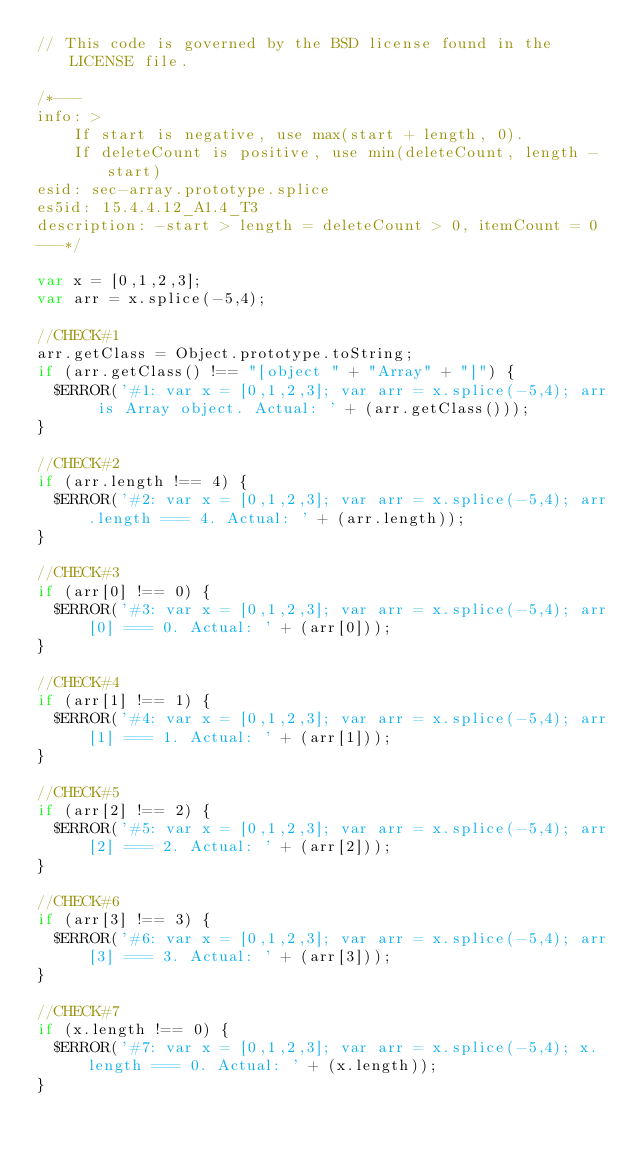Convert code to text. <code><loc_0><loc_0><loc_500><loc_500><_JavaScript_>// This code is governed by the BSD license found in the LICENSE file.

/*---
info: >
    If start is negative, use max(start + length, 0).
    If deleteCount is positive, use min(deleteCount, length - start)
esid: sec-array.prototype.splice
es5id: 15.4.4.12_A1.4_T3
description: -start > length = deleteCount > 0, itemCount = 0
---*/

var x = [0,1,2,3];
var arr = x.splice(-5,4);

//CHECK#1
arr.getClass = Object.prototype.toString;
if (arr.getClass() !== "[object " + "Array" + "]") {
  $ERROR('#1: var x = [0,1,2,3]; var arr = x.splice(-5,4); arr is Array object. Actual: ' + (arr.getClass()));
}

//CHECK#2
if (arr.length !== 4) {
  $ERROR('#2: var x = [0,1,2,3]; var arr = x.splice(-5,4); arr.length === 4. Actual: ' + (arr.length));
}

//CHECK#3
if (arr[0] !== 0) {
  $ERROR('#3: var x = [0,1,2,3]; var arr = x.splice(-5,4); arr[0] === 0. Actual: ' + (arr[0]));
}

//CHECK#4
if (arr[1] !== 1) {
  $ERROR('#4: var x = [0,1,2,3]; var arr = x.splice(-5,4); arr[1] === 1. Actual: ' + (arr[1]));
}

//CHECK#5
if (arr[2] !== 2) {
  $ERROR('#5: var x = [0,1,2,3]; var arr = x.splice(-5,4); arr[2] === 2. Actual: ' + (arr[2]));
}

//CHECK#6
if (arr[3] !== 3) {
  $ERROR('#6: var x = [0,1,2,3]; var arr = x.splice(-5,4); arr[3] === 3. Actual: ' + (arr[3]));
}

//CHECK#7
if (x.length !== 0) {
  $ERROR('#7: var x = [0,1,2,3]; var arr = x.splice(-5,4); x.length === 0. Actual: ' + (x.length));
}
</code> 